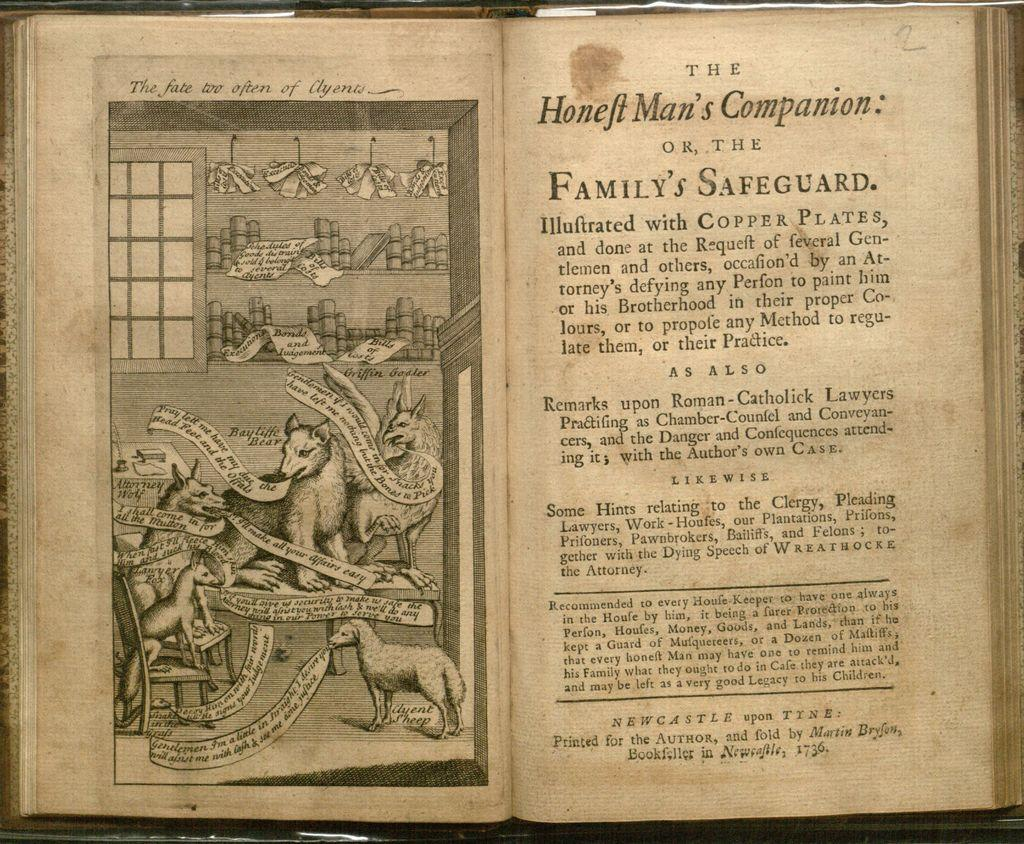<image>
Present a compact description of the photo's key features. A book folded by Martin Bryson and printed in Newcastle in 1736. 